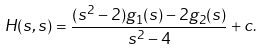Convert formula to latex. <formula><loc_0><loc_0><loc_500><loc_500>H ( s , s ) = \frac { ( s ^ { 2 } - 2 ) g _ { 1 } ( s ) - 2 g _ { 2 } ( s ) } { s ^ { 2 } - 4 } + c .</formula> 